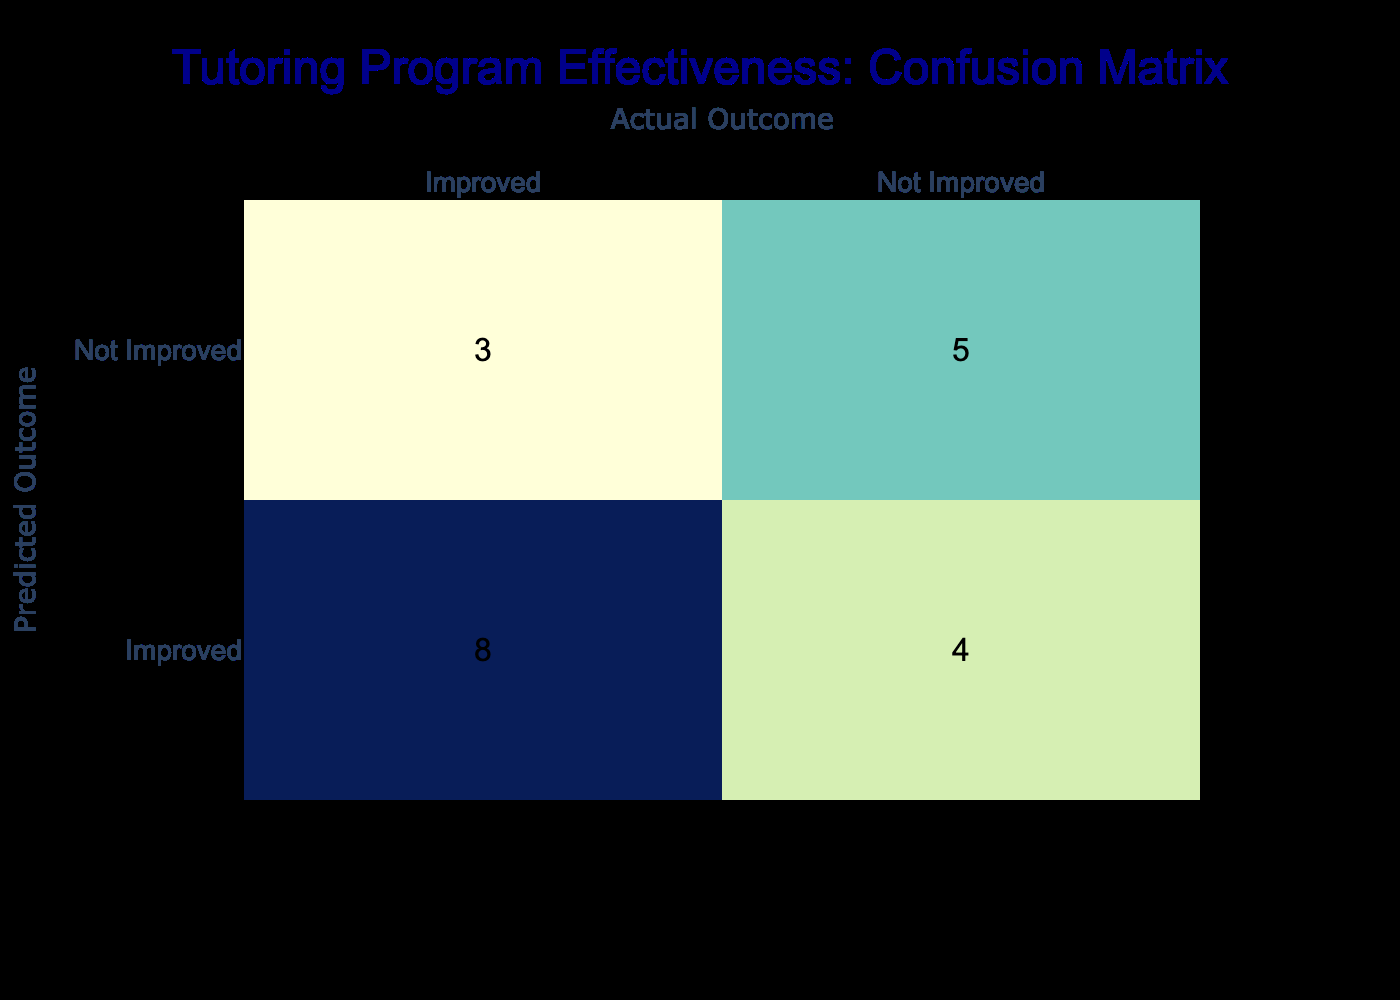What is the number of students who were predicted to improve and actually improved? By looking at the "Predicted" row for "Improved" and counting the corresponding values in the "Actual" column for "Improved", we find that there are 6 students who fit this category (Students 1, 4, 6, 9, 11, and 16).
Answer: 6 What is the total number of students who did not improve according to the actual outcomes? To find the total number of students who did not improve, we need to look at the "Not Improved" column in the "Actual" outcomes. There are 7 students (Students 3, 5, 8, 10, 12, 14, and 15) who did not improve.
Answer: 7 How many students were incorrectly predicted to improve? This is the sum of the cells in the "Predicted" row for "Improved" but "Not Improved" in the "Actual" outcome. Looking at the table, there are 3 such students (Students 2, 8, and 20) who were predicted to improve but did not.
Answer: 3 Is it true that more students improved than did not improve? To determine this, we count the number of students who improved (9) and compare it to those who did not improve (7). Since there are more students who improved, this statement is true.
Answer: Yes What is the difference between the number of correct predictions for improvement and the number of correct predictions for no improvement? From the table, there are 6 correct predictions for improvement and 4 correct predictions for no improvement (Students 3, 7, 10, and 17). The difference between correct predictions for improvement (6) and for no improvement (4) is 2.
Answer: 2 What percentage of students were correctly predicted to improve? There are 6 students correctly predicted to improve out of 20 total students. To find the percentage, we calculate (6/20) * 100, which gives us 30%.
Answer: 30% How many students were predicted to not improve but actually improved? We need to check the "Predicted" row for "Not Improved" and the "Actual" column for "Improved." There are 3 students (Students 5, 12, and 19) who match this condition.
Answer: 3 Which outcome had a higher total count in the actual outcomes: improved or not improved? In the actual outcomes, "Improved" has 9 while "Not Improved" has 7. Since 9 is greater than 7, improved had a higher total count.
Answer: Improved 